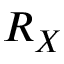<formula> <loc_0><loc_0><loc_500><loc_500>R _ { X }</formula> 